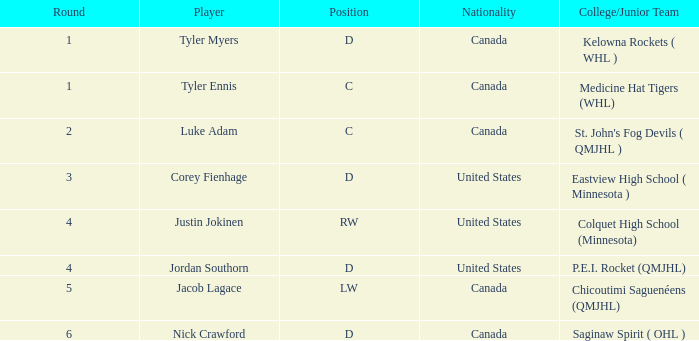What is the combined value of the chosen player in the left-wing position? 134.0. 